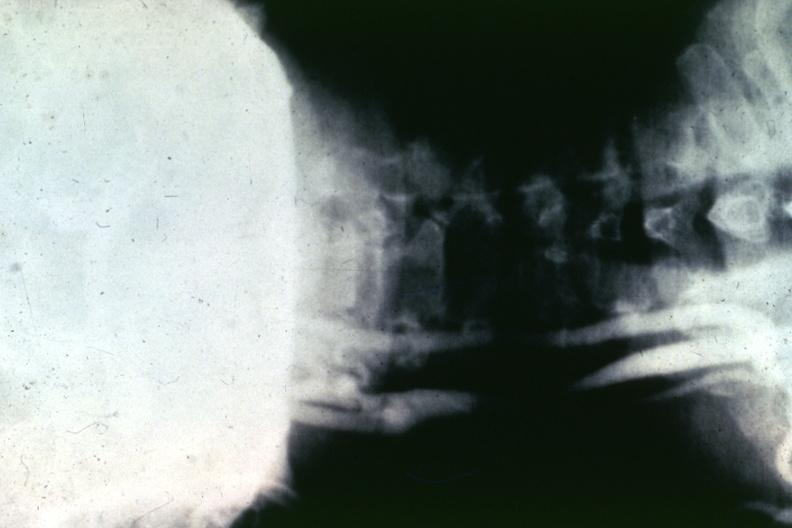what does this image show?
Answer the question using a single word or phrase. Artery 